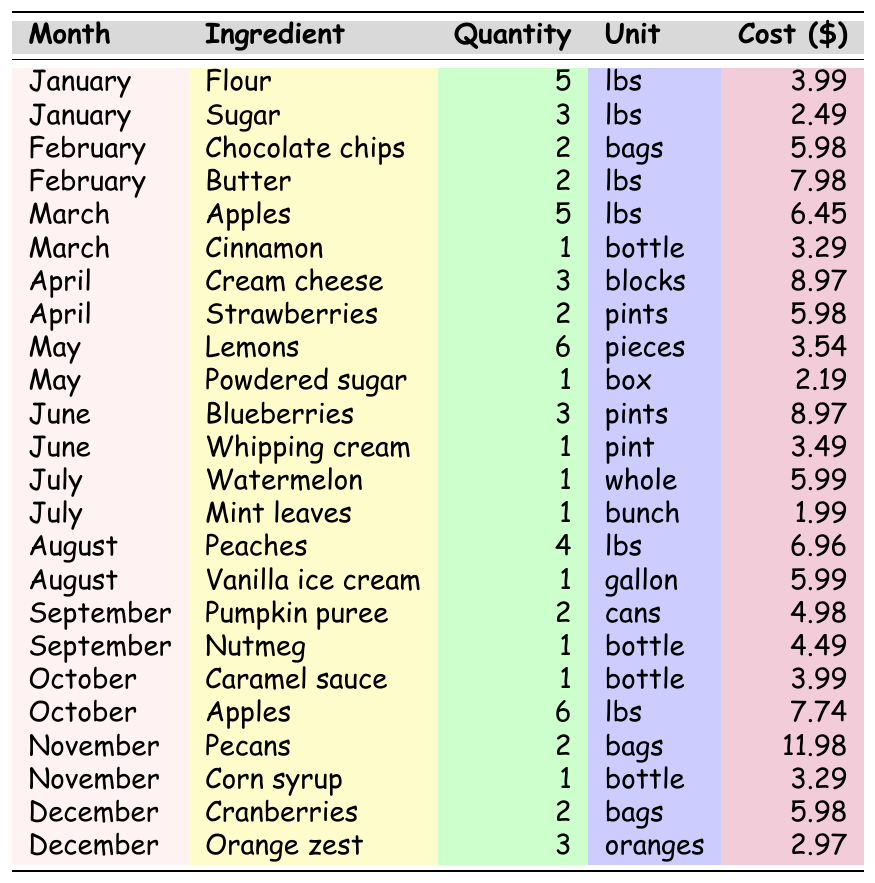What ingredient was used in March and how much did it cost? In March, the ingredients listed are Apples and Cinnamon. The cost for Apples is $6.45 and for Cinnamon is $3.29.
Answer: $6.45 for Apples and $3.29 for Cinnamon How many pounds of Strawberries were purchased in April? The table shows that 2 pints of Strawberries were purchased in April, but the unit is in pints, not pounds.
Answer: 2 pints What is the total cost of all ingredients in June? The ingredients in June are Blueberries ($8.97) and Whipping cream ($3.49). Adding these together: $8.97 + $3.49 = $12.46.
Answer: $12.46 Is the cost of Pumpkin puree greater than the cost of Nutmeg? The cost of Pumpkin puree is $4.98 and the cost of Nutmeg is $4.49. Since $4.98 is greater than $4.49, the statement is true.
Answer: Yes Which month had the highest total ingredient cost? To find the month with the highest cost, sum the costs for all ingredients in each month. For example, January has $3.99 + $2.49 = $6.48, and continuing this for each month, the maximum total is found in November with $11.98 + $3.29 = $15.27.
Answer: November What is the average cost of snacks in August? In August, the costs for Peaches and Vanilla ice cream are $6.96 and $5.99 respectively. The total cost is $6.96 + $5.99 = $12.95, and the average cost is $12.95 / 2 = $6.475.
Answer: $6.475 How many different types of ingredients were used throughout the year? The table lists ingredients for each month. Counting them yields 24 unique ingredients over the year.
Answer: 24 Did December use any ingredients that were used before the month of December? Reviewing the table, December has Cranberries and Orange zest. All other months, especially prior months (January to November), used various ingredients like Sugar, Butter, and Apples. Since Apples are used in October, the statement is true.
Answer: Yes Calculate the total quantity of ingredients used in July. In July, Watermelon (1 whole) and Mint leaves (1 bunch) were used. The total quantity is 1 + 1 = 2.
Answer: 2 Which ingredient was the most expensive in the table and what was its cost? Examining the costs of all ingredients, Pecans in November cost $11.98, making it the most expensive ingredient.
Answer: Pecans for $11.98 